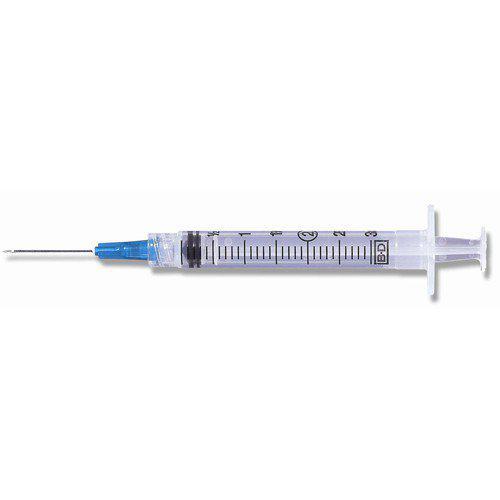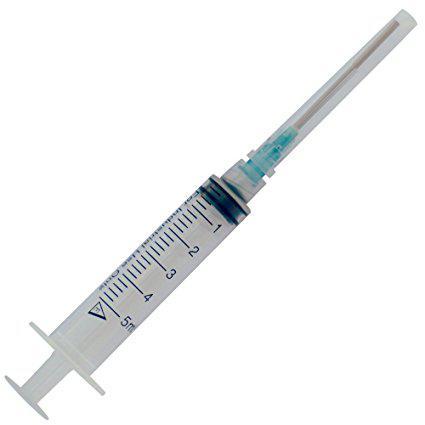The first image is the image on the left, the second image is the image on the right. Analyze the images presented: Is the assertion "There is a total of two syringes with no plastic bags." valid? Answer yes or no. Yes. The first image is the image on the left, the second image is the image on the right. For the images shown, is this caption "One of the images shows a single syringe and another image shows two syringes that are parallel to one another." true? Answer yes or no. No. 